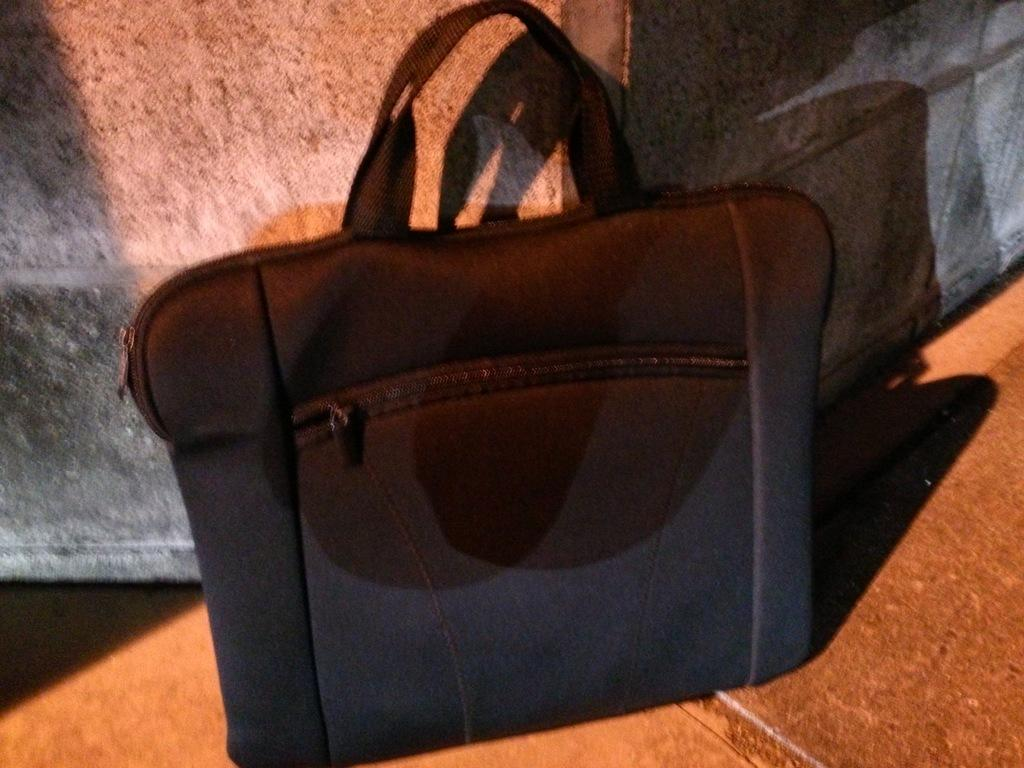What is the color of the bag in the image? The bag in the image is black. Where is the bag located in the image? The bag is placed on the floor. What feature does the bag have in the front? The bag has a zip in front of it. Can you hear the song playing from the ball in the image? There is no ball or song present in the image; it only features a black bag placed on the floor. 